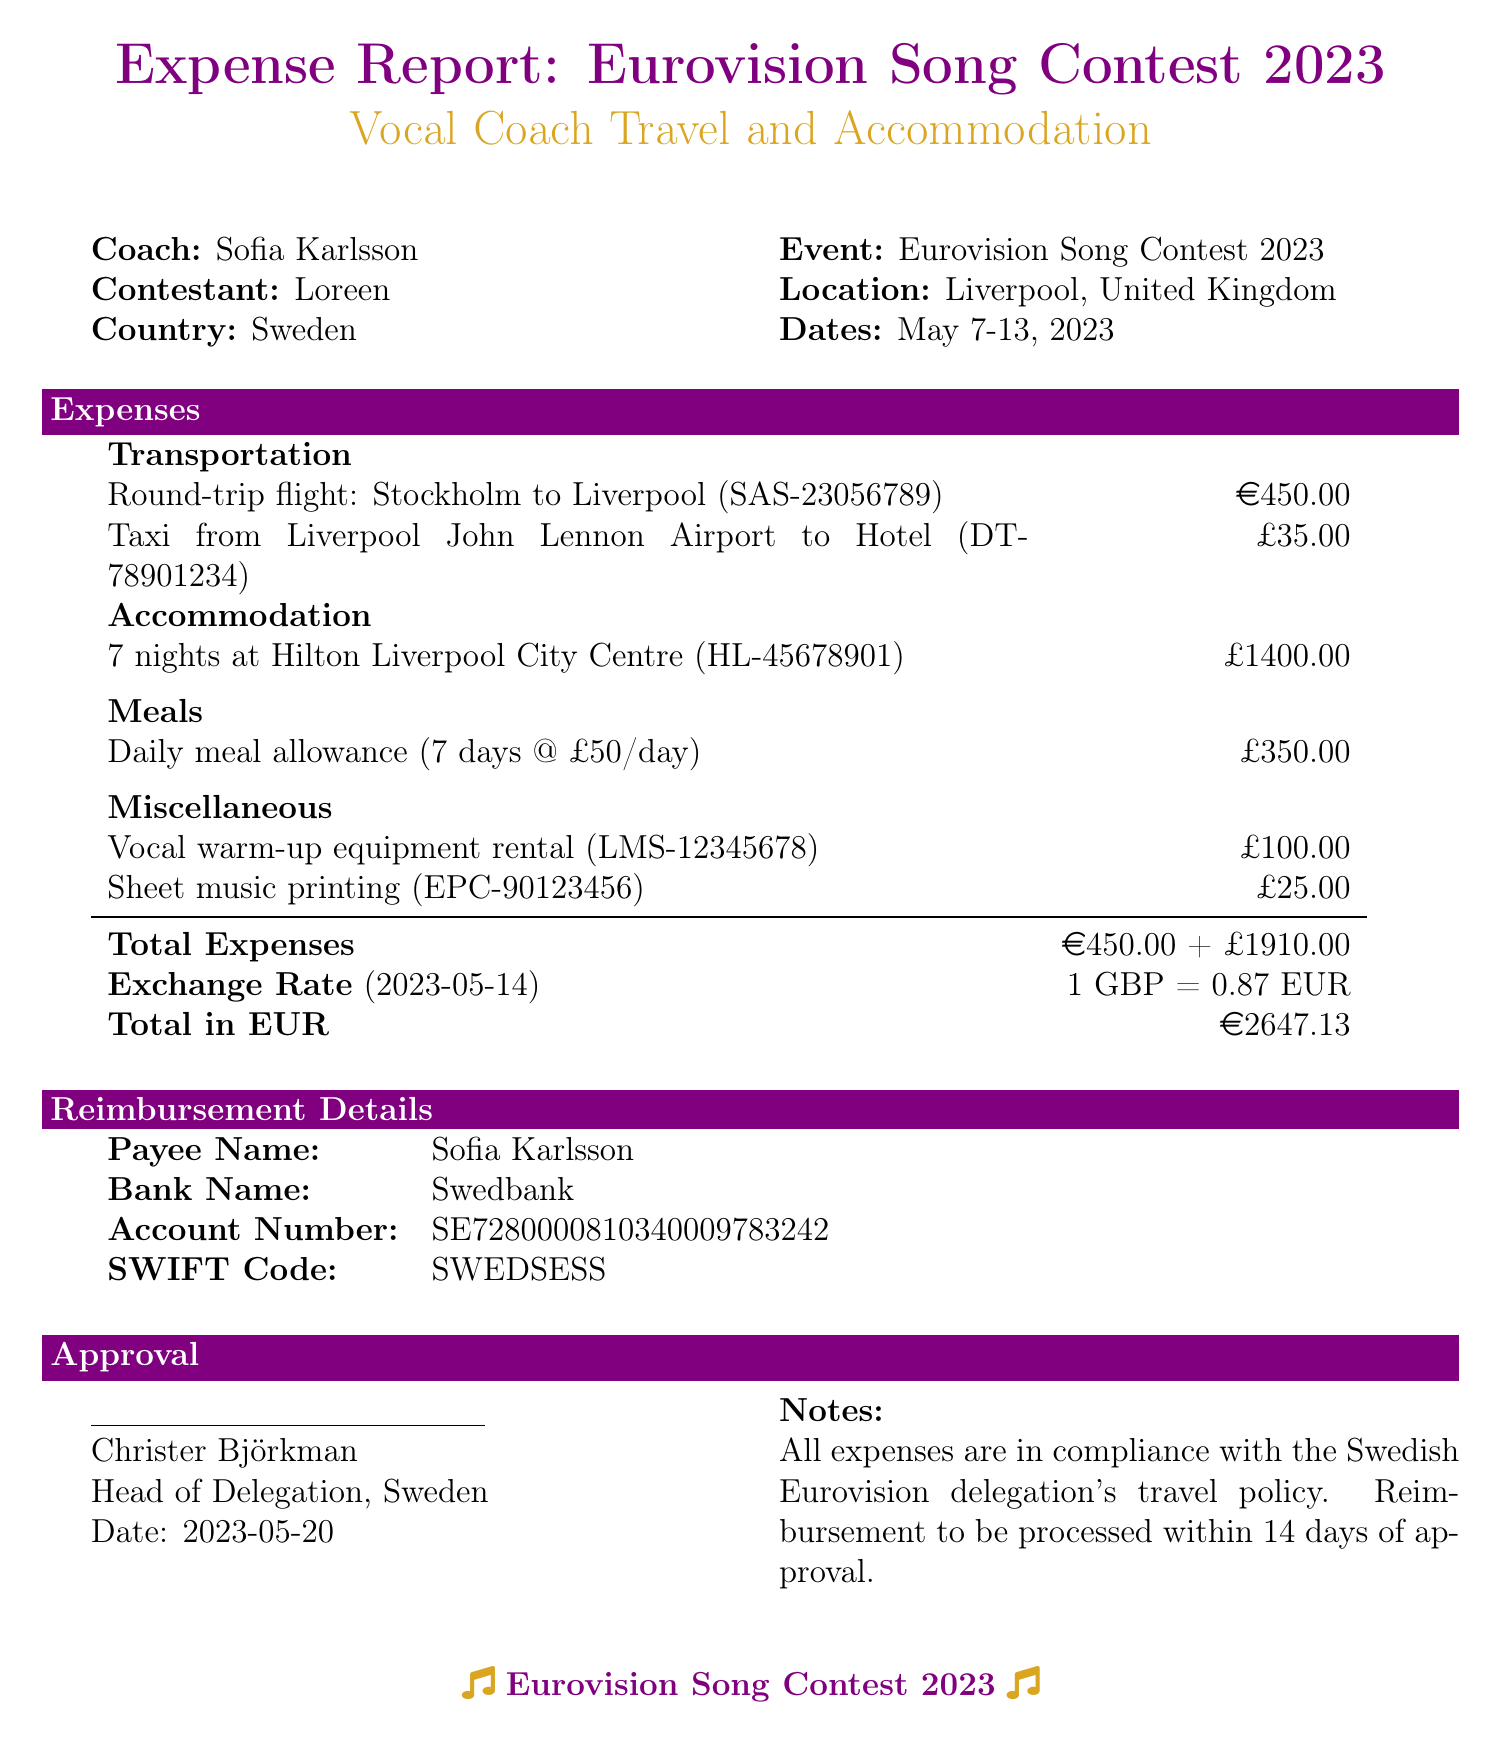what is the coach's name? The coach's name is mentioned at the beginning of the document.
Answer: Sofia Karlsson what is the contestant's name? The contestant's name is specified alongside the coach's name.
Answer: Loreen what was the total accommodation cost? The total cost for accommodation is listed under the Accommodation category.
Answer: £1400.00 what was the total amount for meals? The total amount for meals is detailed in the Meals category for the daily meal allowance.
Answer: £350.00 how many nights did the coach stay at the hotel? The duration of stay is specified in the Accommodation section.
Answer: 7 nights what is the total expense in euros? The total expenses in euros are clearly stated at the bottom of the expense report.
Answer: €2647.13 what is the reimbursement processing time? The notes section indicates how long the reimbursement will take after approval.
Answer: 14 days which airline was used for the flight? The airline is mentioned next to the transportation expense for the round-trip flight.
Answer: Scandinavian Airlines who signed the approval? The approval signature section identifies the person who approved the expenses.
Answer: Christer Björkman 